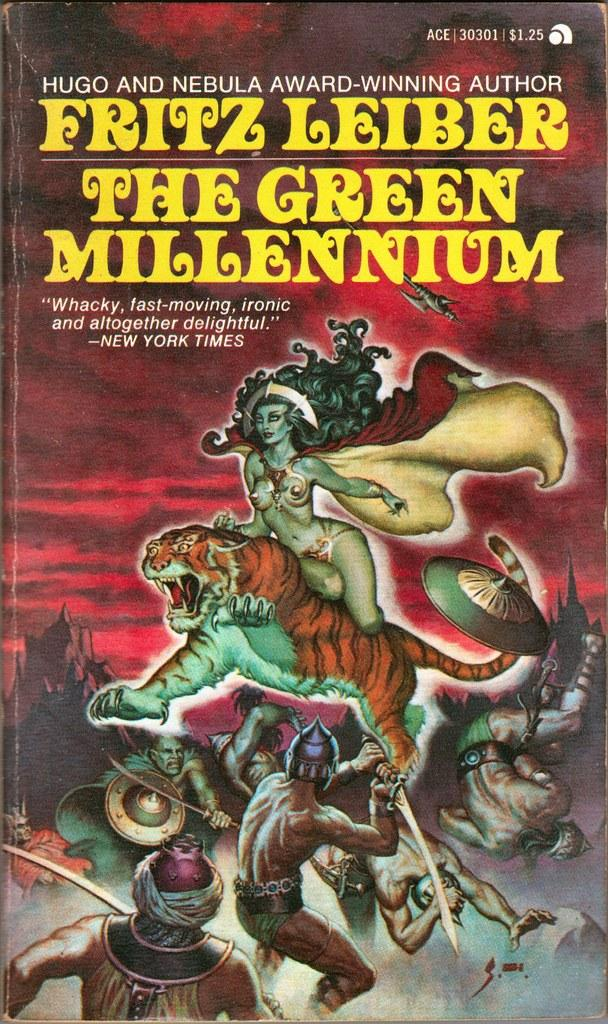Provide a one-sentence caption for the provided image. Book with a tiger and warrior on the cover named "The Green Millennium". 